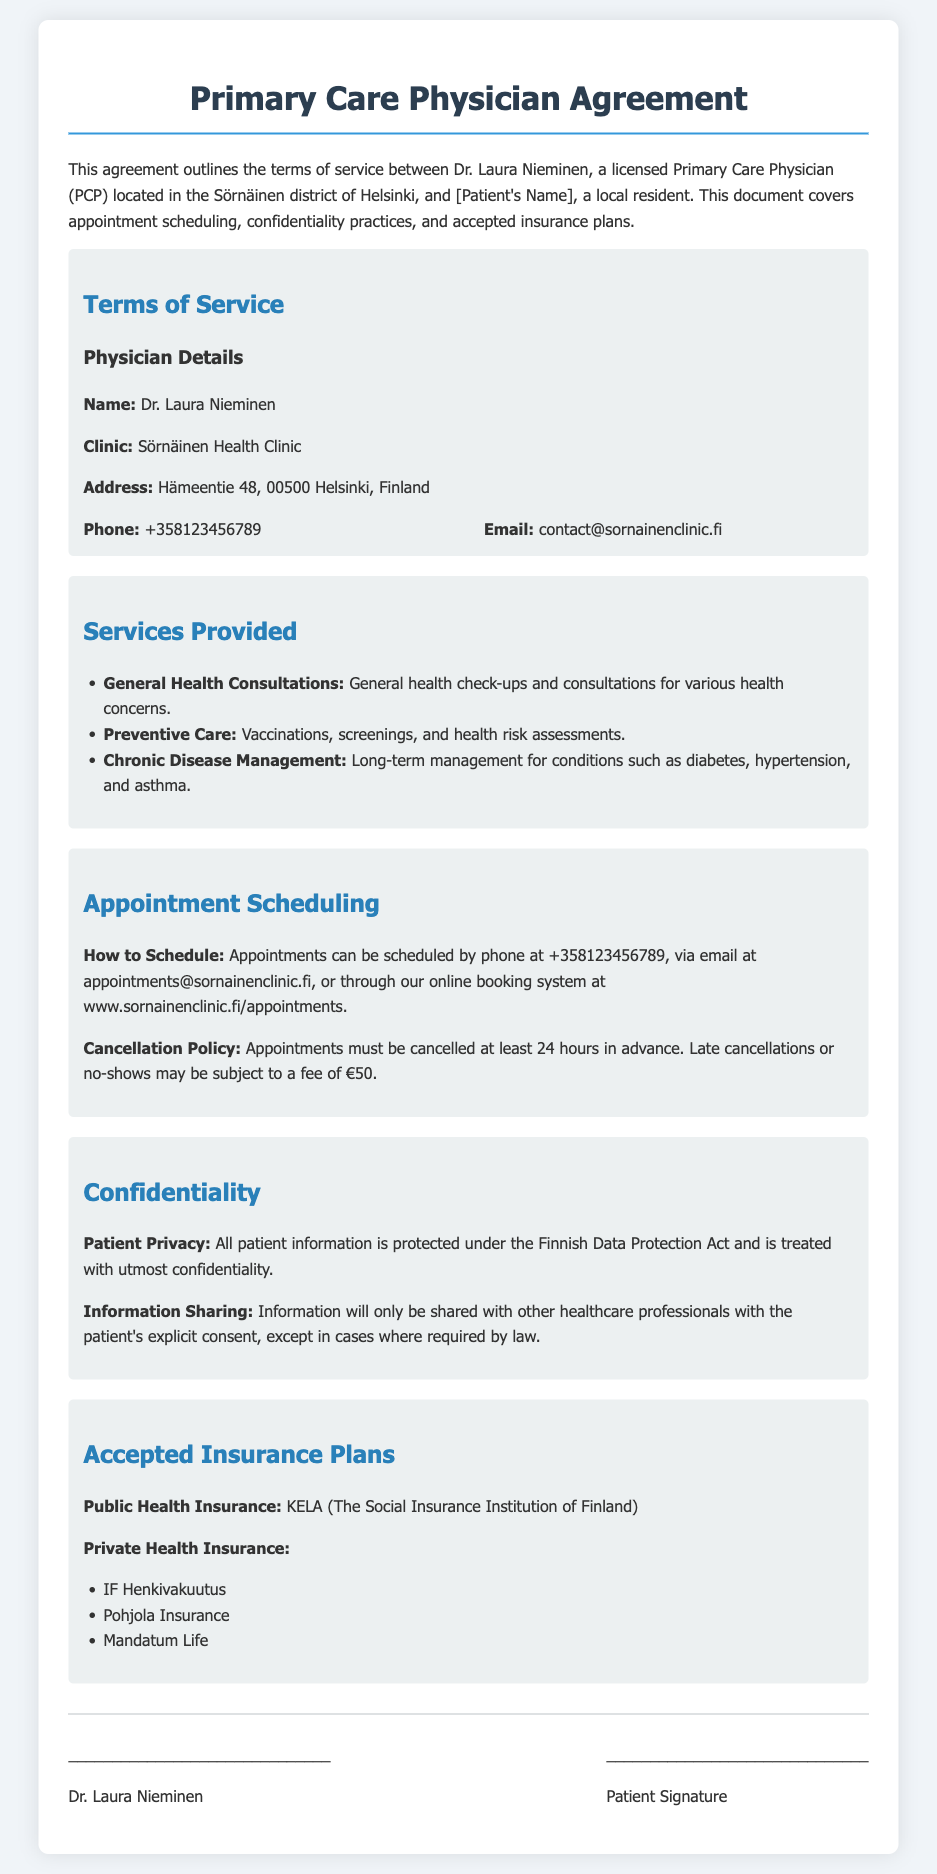What is the physician's name? The name of the physician is mentioned in the agreement as Dr. Laura Nieminen.
Answer: Dr. Laura Nieminen What is the clinic's address? The address of the clinic is provided in the terms of service section of the document.
Answer: Hämeentie 48, 00500 Helsinki, Finland What is the phone number to schedule appointments? The phone number for appointment scheduling is specified in the appointment scheduling section.
Answer: +358123456789 What is the cancellation fee for late cancellations? The document outlines the cancellation policy, including the fee for late cancellations.
Answer: €50 What type of care does the clinic provide? The document lists various services provided by the clinic including general health consultations and preventive care.
Answer: General health consultations, preventive care, chronic disease management What is the patient privacy law referenced in the document? The confidentiality section refers to the law protecting patient information, which is relevant to privacy practices.
Answer: Finnish Data Protection Act How can appointments be scheduled? The appointment scheduling section explains the methods available for scheduling appointments.
Answer: Phone, email, online booking system What type of insurance is accepted? The document specifies the accepted insurance plans under the accepted insurance plans section.
Answer: KELA (The Social Insurance Institution of Finland), IF Henkivakuutus, Pohjola Insurance, Mandatum Life 